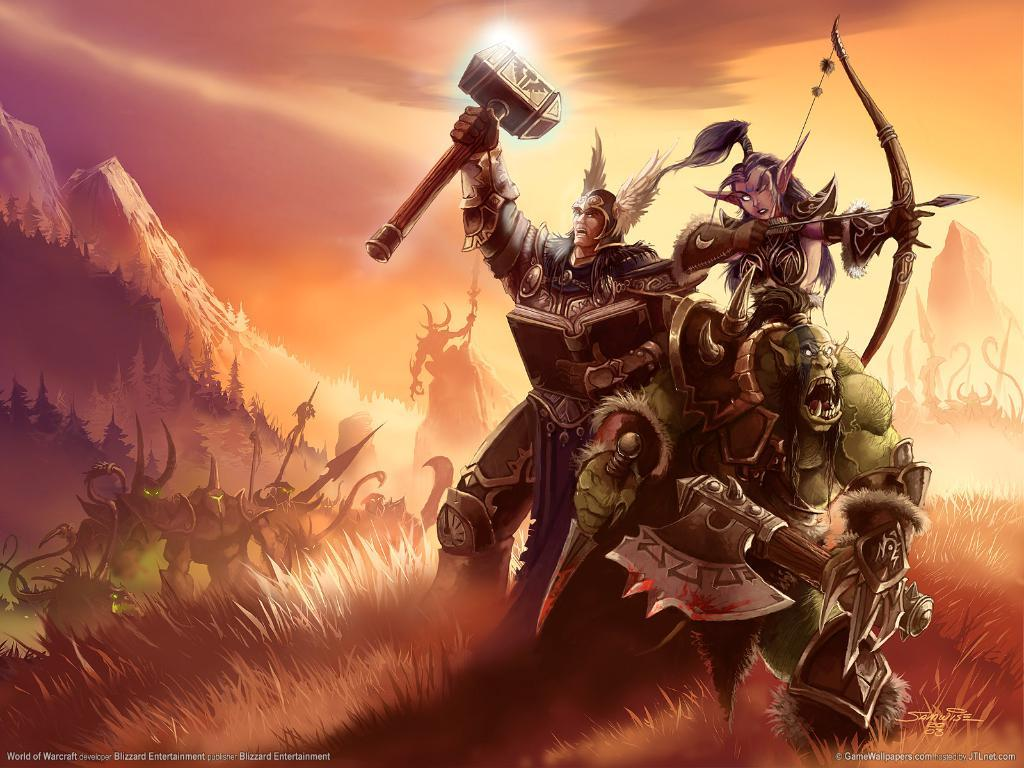What type of characters can be seen in the grass in the image? There are cartoons in the grass. What geographical feature is present in the image? There is a mountain in the image. What part of the natural environment is visible in the image? The sky is visible in the image. Where is the book located in the image? There is no book present in the image. What type of ants can be seen crawling on the mountain in the image? There are no ants present in the image, and the mountain does not have any visible ants. 